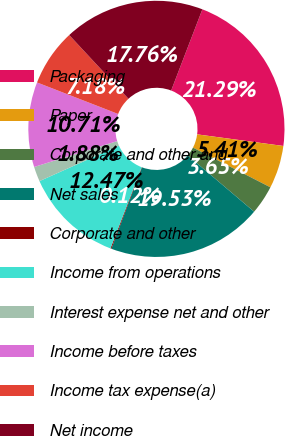Convert chart to OTSL. <chart><loc_0><loc_0><loc_500><loc_500><pie_chart><fcel>Packaging<fcel>Paper<fcel>Corporate and other and<fcel>Net sales<fcel>Corporate and other<fcel>Income from operations<fcel>Interest expense net and other<fcel>Income before taxes<fcel>Income tax expense(a)<fcel>Net income<nl><fcel>21.29%<fcel>5.41%<fcel>3.65%<fcel>19.53%<fcel>0.12%<fcel>12.47%<fcel>1.88%<fcel>10.71%<fcel>7.18%<fcel>17.76%<nl></chart> 